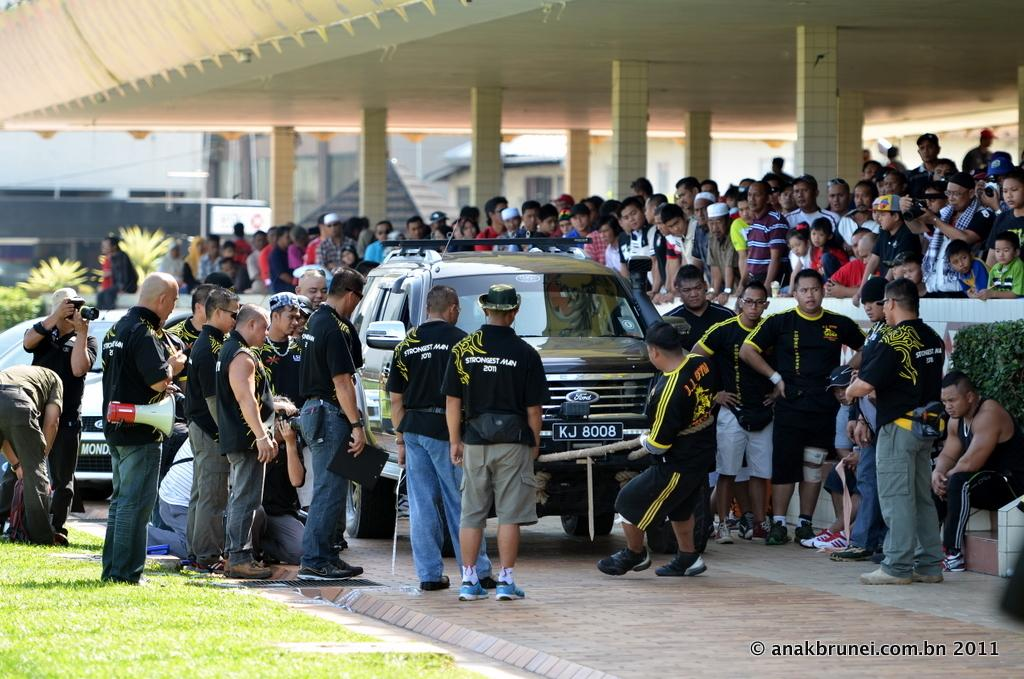What is the main subject of the image? The main subject of the image is a crowd. Where is the crowd located? The crowd is standing under the roof top of a building. What is the crowd watching? The crowd is watching a car. How is the car being moved? The car is being pulled by a man using a rope. What type of box is the father using to increase his profit in the image? There is no box, father, or mention of profit in the image. The image depicts a crowd watching a man pulling a car with a rope. 